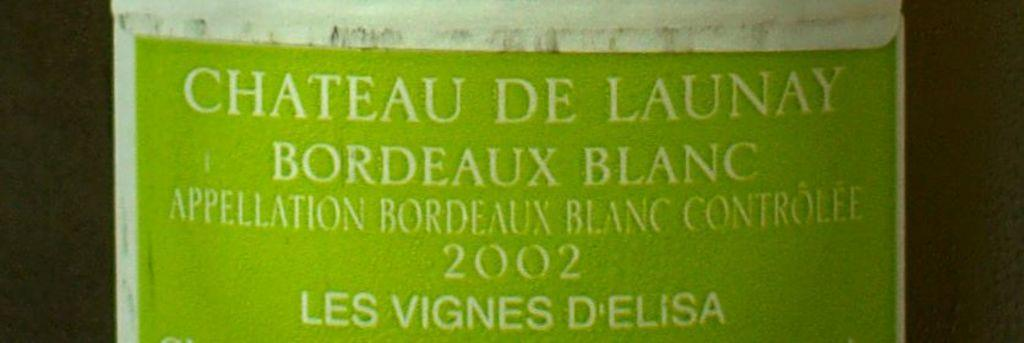Provide a one-sentence caption for the provided image. The label for this Chateau De Launay bordeaux blanc is light green. 